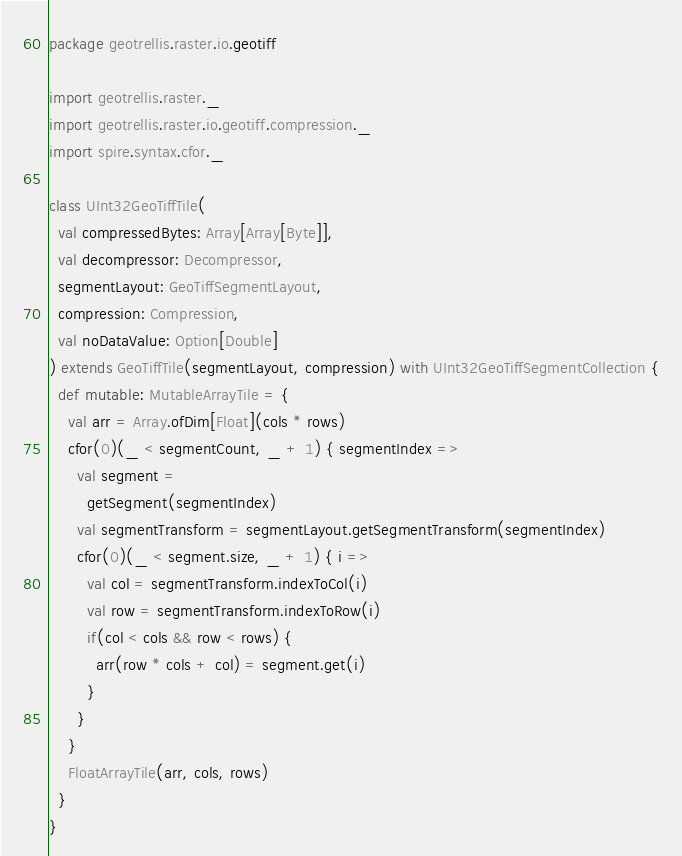Convert code to text. <code><loc_0><loc_0><loc_500><loc_500><_Scala_>package geotrellis.raster.io.geotiff

import geotrellis.raster._
import geotrellis.raster.io.geotiff.compression._
import spire.syntax.cfor._

class UInt32GeoTiffTile(
  val compressedBytes: Array[Array[Byte]],
  val decompressor: Decompressor,
  segmentLayout: GeoTiffSegmentLayout,
  compression: Compression,
  val noDataValue: Option[Double]
) extends GeoTiffTile(segmentLayout, compression) with UInt32GeoTiffSegmentCollection {
  def mutable: MutableArrayTile = {
    val arr = Array.ofDim[Float](cols * rows)
    cfor(0)(_ < segmentCount, _ + 1) { segmentIndex =>
      val segment = 
        getSegment(segmentIndex)
      val segmentTransform = segmentLayout.getSegmentTransform(segmentIndex)
      cfor(0)(_ < segment.size, _ + 1) { i =>
        val col = segmentTransform.indexToCol(i)
        val row = segmentTransform.indexToRow(i)
        if(col < cols && row < rows) {
          arr(row * cols + col) = segment.get(i)
        }
      }
    }
    FloatArrayTile(arr, cols, rows)
  }
}
</code> 